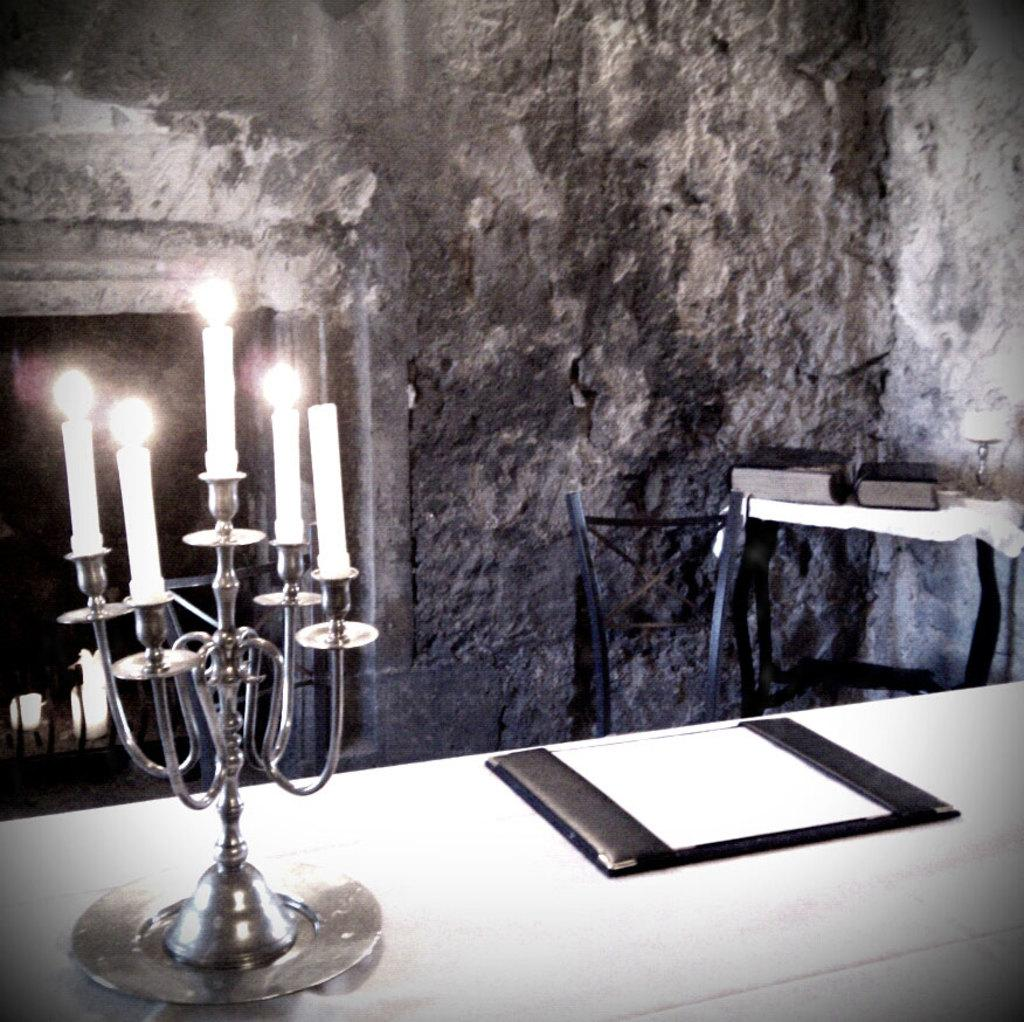What objects can be seen in the image that provide light? There are candles in the image that provide light. What is on the table in the image? There is a card and books on the table in the image. What piece of furniture is present in the image? There is a chair in the image. What is visible in the background of the image? There is a wall in the image. What type of produce can be seen growing on the wall in the image? There is no produce visible in the image; the wall is not shown to have any plants or fruits growing on it. 